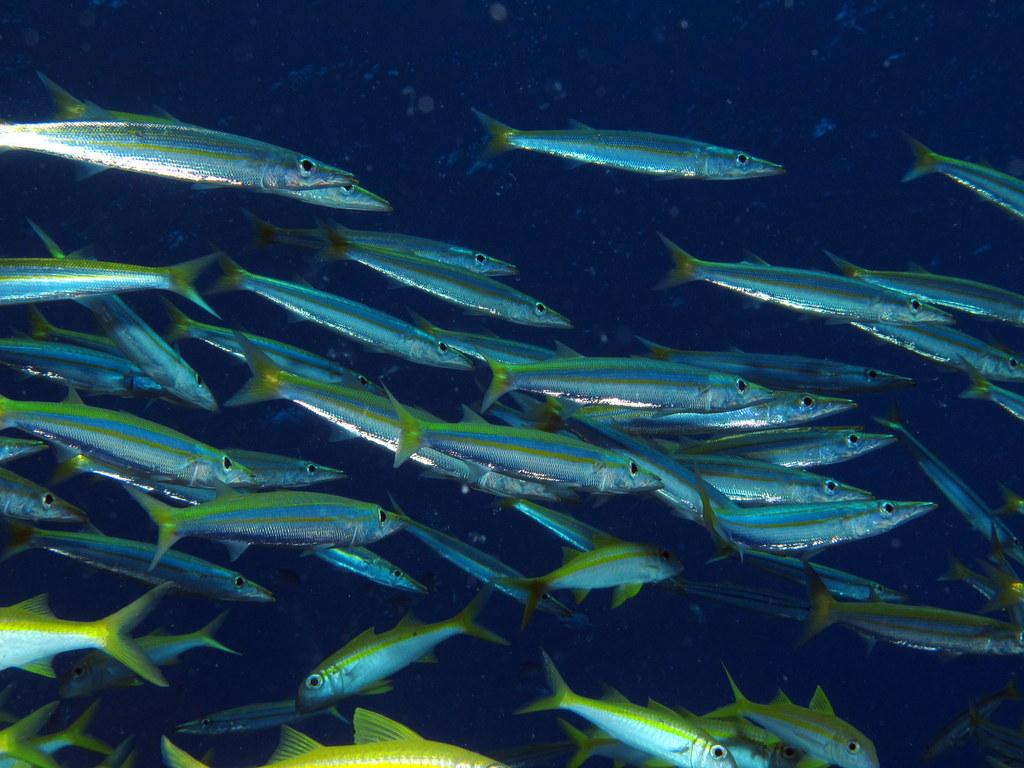What type of animals can be seen in the image? There are fishes in the image. What are the fishes doing in the image? The fishes are swimming in the water. What type of building can be seen in the image? There is no building present in the image; it features fishes swimming in the water. What is the faucet used for in the image? There is no faucet present in the image. 